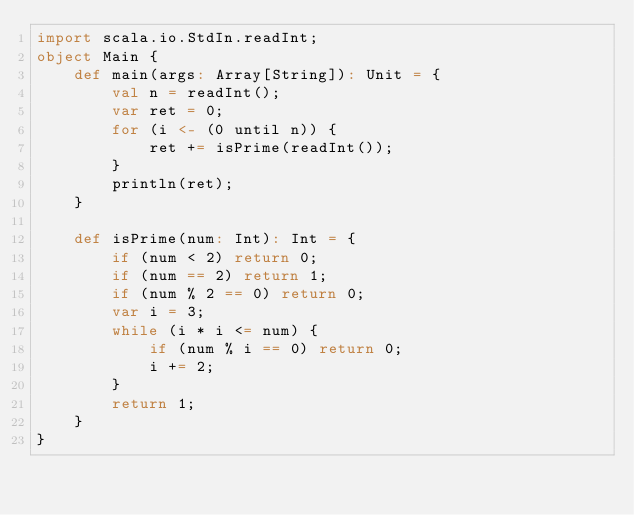<code> <loc_0><loc_0><loc_500><loc_500><_Scala_>import scala.io.StdIn.readInt;
object Main {
    def main(args: Array[String]): Unit = {
        val n = readInt();
        var ret = 0;
        for (i <- (0 until n)) {
            ret += isPrime(readInt());
        }
        println(ret);
    }
    
    def isPrime(num: Int): Int = {
        if (num < 2) return 0;
        if (num == 2) return 1;
        if (num % 2 == 0) return 0;
        var i = 3;
        while (i * i <= num) {
            if (num % i == 0) return 0;
            i += 2;
        }
        return 1;
    }
}
</code> 